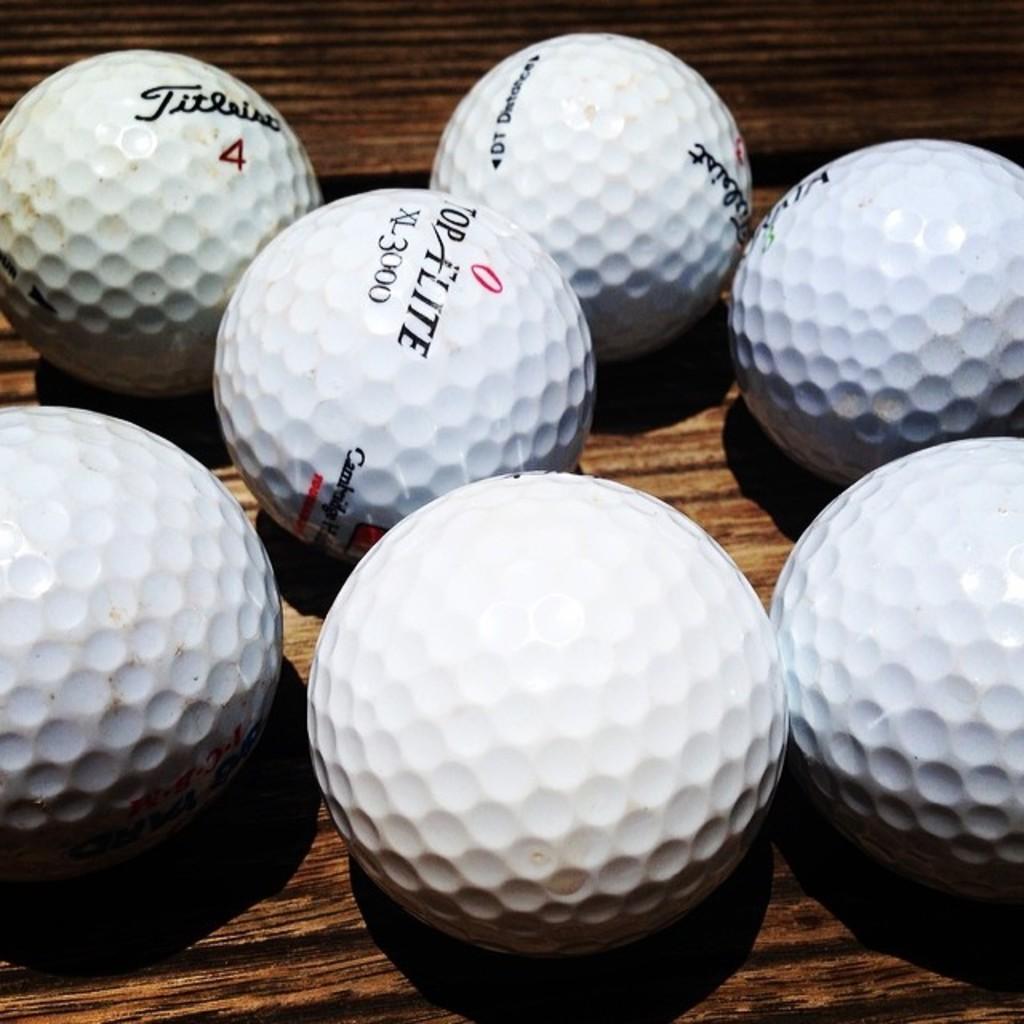Could you give a brief overview of what you see in this image? In this image we a few golf balls kept on the wooden surface. 